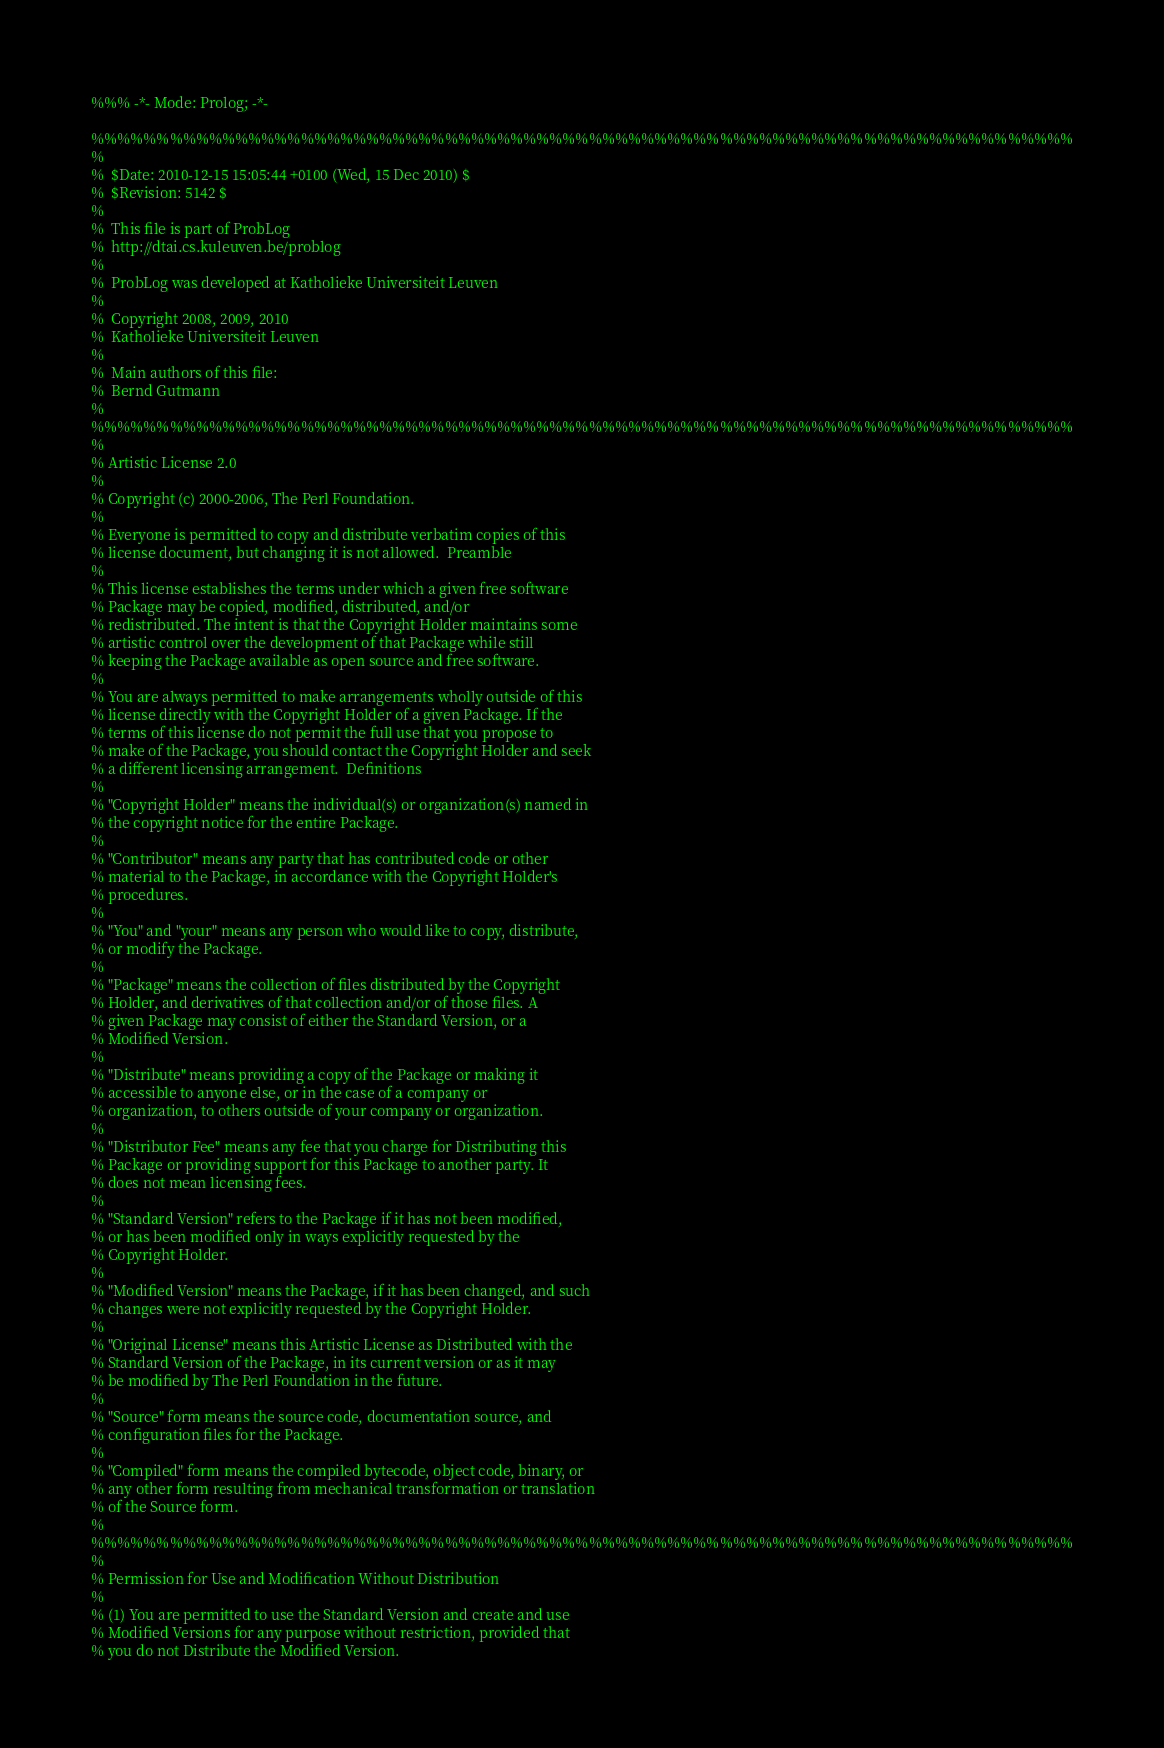<code> <loc_0><loc_0><loc_500><loc_500><_Prolog_>%%% -*- Mode: Prolog; -*-

%%%%%%%%%%%%%%%%%%%%%%%%%%%%%%%%%%%%%%%%%%%%%%%%%%%%%%%%%%%%%%%%%%%%%%%%%%%
%
%  $Date: 2010-12-15 15:05:44 +0100 (Wed, 15 Dec 2010) $
%  $Revision: 5142 $
%
%  This file is part of ProbLog
%  http://dtai.cs.kuleuven.be/problog
%
%  ProbLog was developed at Katholieke Universiteit Leuven
%
%  Copyright 2008, 2009, 2010
%  Katholieke Universiteit Leuven
%
%  Main authors of this file:
%  Bernd Gutmann
%
%%%%%%%%%%%%%%%%%%%%%%%%%%%%%%%%%%%%%%%%%%%%%%%%%%%%%%%%%%%%%%%%%%%%%%%%%%%
%
% Artistic License 2.0
% 
% Copyright (c) 2000-2006, The Perl Foundation.
% 
% Everyone is permitted to copy and distribute verbatim copies of this
% license document, but changing it is not allowed.  Preamble
% 
% This license establishes the terms under which a given free software
% Package may be copied, modified, distributed, and/or
% redistributed. The intent is that the Copyright Holder maintains some
% artistic control over the development of that Package while still
% keeping the Package available as open source and free software.
% 
% You are always permitted to make arrangements wholly outside of this
% license directly with the Copyright Holder of a given Package. If the
% terms of this license do not permit the full use that you propose to
% make of the Package, you should contact the Copyright Holder and seek
% a different licensing arrangement.  Definitions
% 
% "Copyright Holder" means the individual(s) or organization(s) named in
% the copyright notice for the entire Package.
% 
% "Contributor" means any party that has contributed code or other
% material to the Package, in accordance with the Copyright Holder's
% procedures.
% 
% "You" and "your" means any person who would like to copy, distribute,
% or modify the Package.
% 
% "Package" means the collection of files distributed by the Copyright
% Holder, and derivatives of that collection and/or of those files. A
% given Package may consist of either the Standard Version, or a
% Modified Version.
% 
% "Distribute" means providing a copy of the Package or making it
% accessible to anyone else, or in the case of a company or
% organization, to others outside of your company or organization.
% 
% "Distributor Fee" means any fee that you charge for Distributing this
% Package or providing support for this Package to another party. It
% does not mean licensing fees.
% 
% "Standard Version" refers to the Package if it has not been modified,
% or has been modified only in ways explicitly requested by the
% Copyright Holder.
% 
% "Modified Version" means the Package, if it has been changed, and such
% changes were not explicitly requested by the Copyright Holder.
% 
% "Original License" means this Artistic License as Distributed with the
% Standard Version of the Package, in its current version or as it may
% be modified by The Perl Foundation in the future.
% 
% "Source" form means the source code, documentation source, and
% configuration files for the Package.
% 
% "Compiled" form means the compiled bytecode, object code, binary, or
% any other form resulting from mechanical transformation or translation
% of the Source form.
%
%%%%%%%%%%%%%%%%%%%%%%%%%%%%%%%%%%%%%%%%%%%%%%%%%%%%%%%%%%%%%%%%%%%%%%%%%%%
%
% Permission for Use and Modification Without Distribution
% 
% (1) You are permitted to use the Standard Version and create and use
% Modified Versions for any purpose without restriction, provided that
% you do not Distribute the Modified Version.</code> 